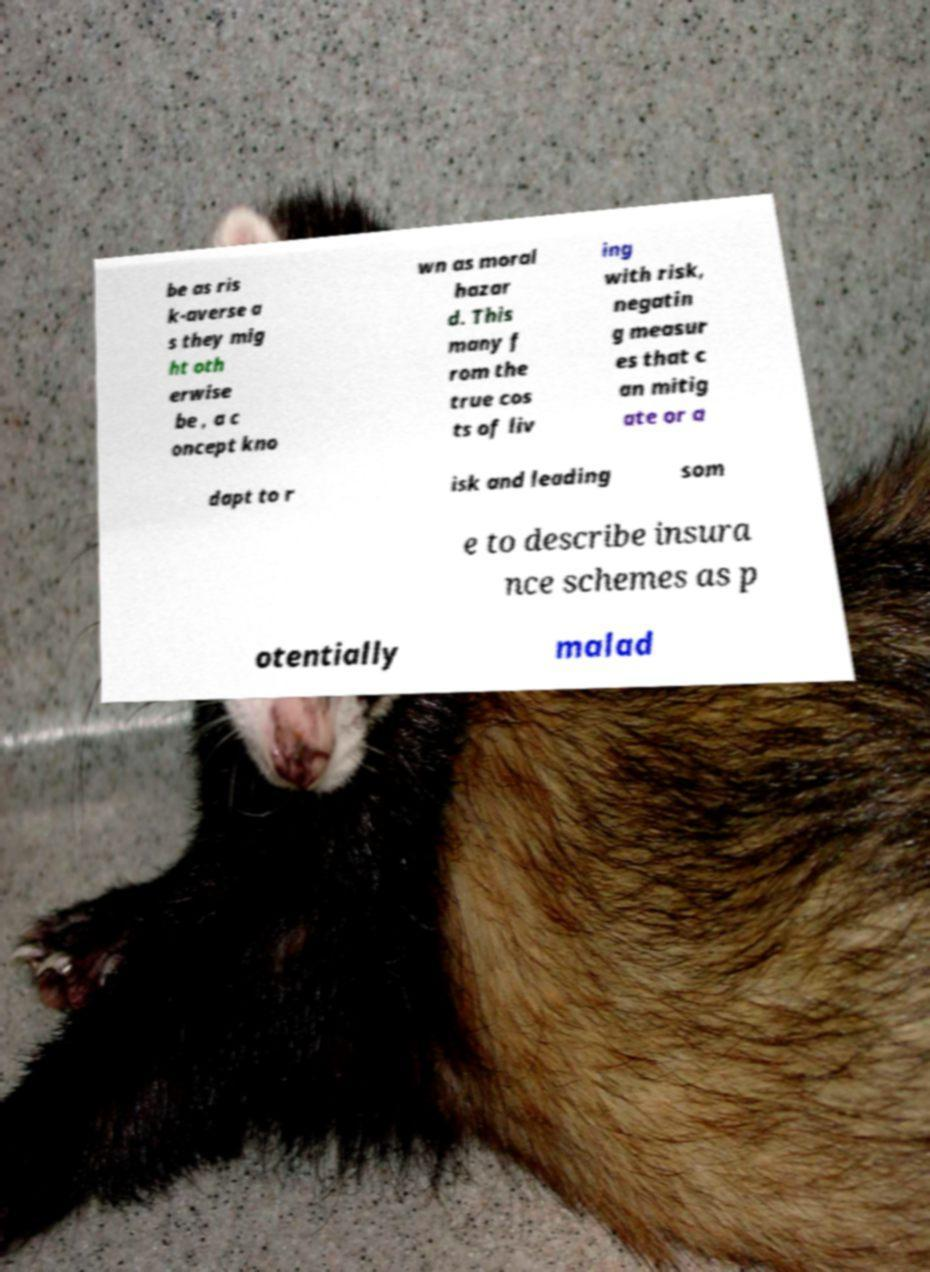Could you assist in decoding the text presented in this image and type it out clearly? be as ris k-averse a s they mig ht oth erwise be , a c oncept kno wn as moral hazar d. This many f rom the true cos ts of liv ing with risk, negatin g measur es that c an mitig ate or a dapt to r isk and leading som e to describe insura nce schemes as p otentially malad 